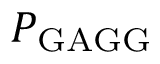<formula> <loc_0><loc_0><loc_500><loc_500>P _ { G A G G }</formula> 